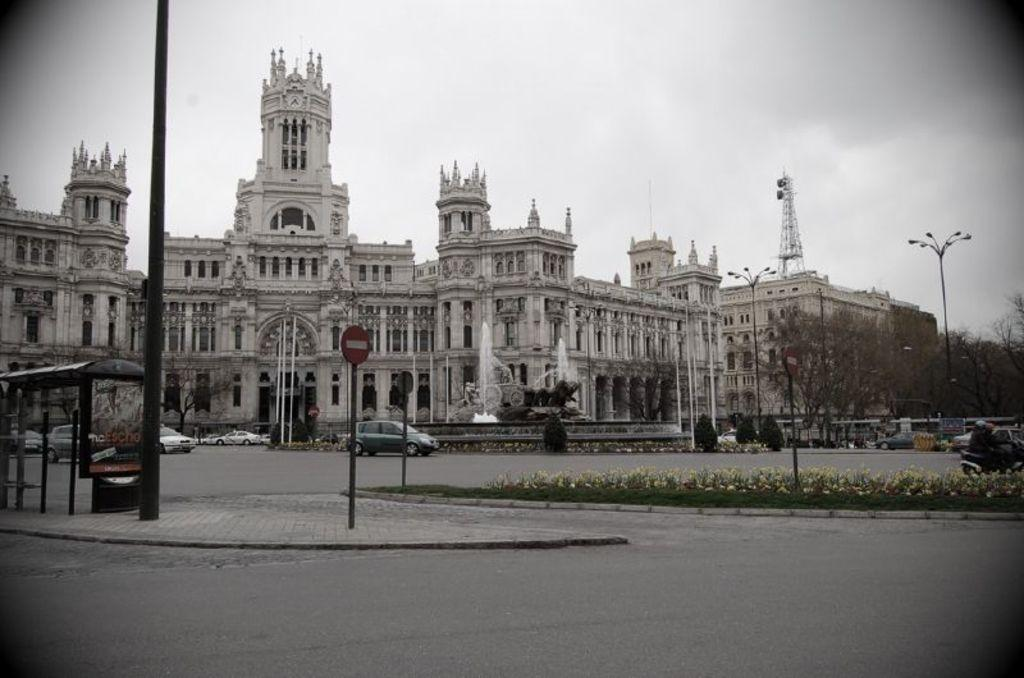What can be seen on the road in the image? There are cars on the road in the image. What objects are present in the image besides the cars? There are poles, plants, buildings with windows, and trees in the image. Can you describe the buildings in the image? The buildings have windows. What is visible in the background of the image? The sky with clouds is visible in the background of the image. Where is the boat located in the image? There is no boat present in the image. What type of light is emitted from the plants in the image? The plants in the image do not emit any light; they are not bioluminescent. 